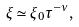Convert formula to latex. <formula><loc_0><loc_0><loc_500><loc_500>\xi \simeq \xi _ { 0 } \tau ^ { - \nu } ,</formula> 